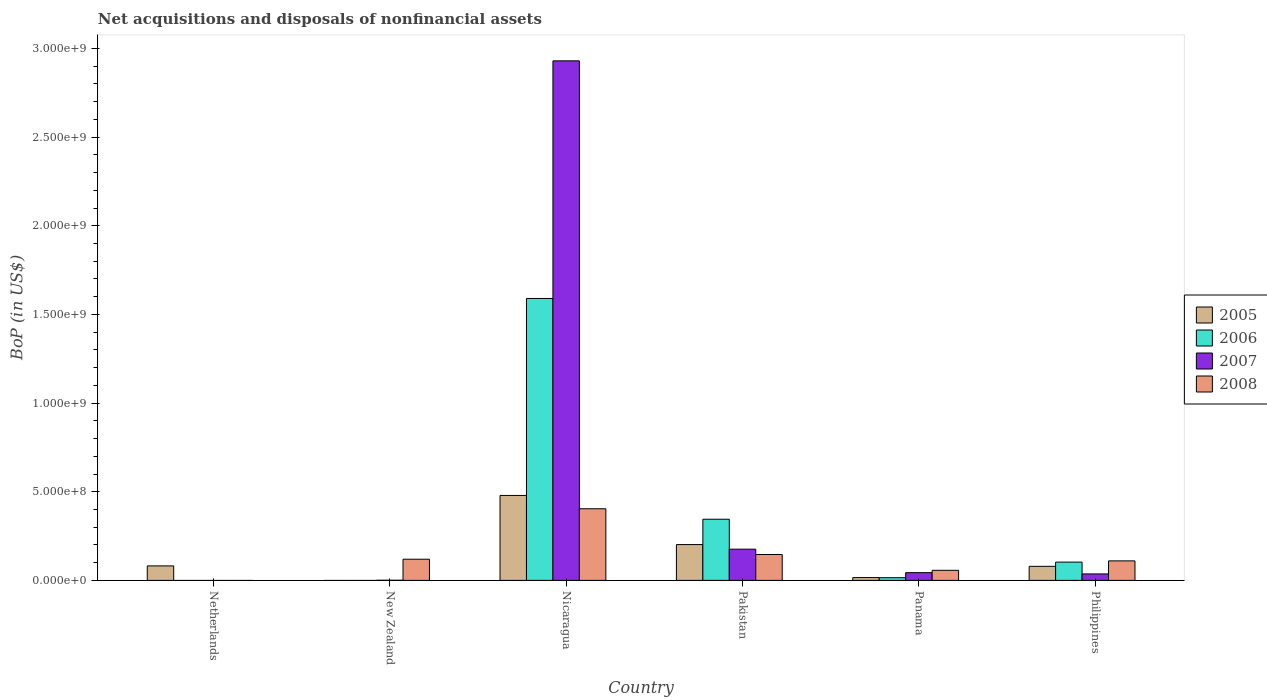Are the number of bars on each tick of the X-axis equal?
Provide a succinct answer. No. How many bars are there on the 6th tick from the left?
Provide a short and direct response. 4. How many bars are there on the 6th tick from the right?
Provide a succinct answer. 1. What is the label of the 6th group of bars from the left?
Ensure brevity in your answer.  Philippines. In how many cases, is the number of bars for a given country not equal to the number of legend labels?
Give a very brief answer. 2. What is the Balance of Payments in 2005 in Philippines?
Offer a very short reply. 7.93e+07. Across all countries, what is the maximum Balance of Payments in 2005?
Make the answer very short. 4.79e+08. Across all countries, what is the minimum Balance of Payments in 2007?
Your answer should be compact. 0. In which country was the Balance of Payments in 2005 maximum?
Offer a terse response. Nicaragua. What is the total Balance of Payments in 2006 in the graph?
Keep it short and to the point. 2.05e+09. What is the difference between the Balance of Payments in 2005 in Pakistan and that in Panama?
Offer a terse response. 1.86e+08. What is the difference between the Balance of Payments in 2007 in Pakistan and the Balance of Payments in 2008 in Nicaragua?
Offer a very short reply. -2.28e+08. What is the average Balance of Payments in 2007 per country?
Provide a short and direct response. 5.31e+08. What is the difference between the Balance of Payments of/in 2005 and Balance of Payments of/in 2008 in Panama?
Give a very brief answer. -4.11e+07. What is the ratio of the Balance of Payments in 2007 in Nicaragua to that in Philippines?
Your answer should be very brief. 80.41. Is the difference between the Balance of Payments in 2005 in Pakistan and Panama greater than the difference between the Balance of Payments in 2008 in Pakistan and Panama?
Offer a terse response. Yes. What is the difference between the highest and the second highest Balance of Payments in 2006?
Make the answer very short. 1.49e+09. What is the difference between the highest and the lowest Balance of Payments in 2008?
Provide a succinct answer. 4.04e+08. In how many countries, is the Balance of Payments in 2008 greater than the average Balance of Payments in 2008 taken over all countries?
Your response must be concise. 2. Is the sum of the Balance of Payments in 2007 in New Zealand and Philippines greater than the maximum Balance of Payments in 2005 across all countries?
Offer a terse response. No. Is it the case that in every country, the sum of the Balance of Payments in 2007 and Balance of Payments in 2008 is greater than the sum of Balance of Payments in 2005 and Balance of Payments in 2006?
Make the answer very short. No. Is it the case that in every country, the sum of the Balance of Payments in 2007 and Balance of Payments in 2006 is greater than the Balance of Payments in 2008?
Ensure brevity in your answer.  No. How many bars are there?
Make the answer very short. 19. Are all the bars in the graph horizontal?
Your answer should be very brief. No. How many countries are there in the graph?
Your answer should be compact. 6. Does the graph contain grids?
Your answer should be compact. No. Where does the legend appear in the graph?
Give a very brief answer. Center right. How many legend labels are there?
Offer a very short reply. 4. What is the title of the graph?
Give a very brief answer. Net acquisitions and disposals of nonfinancial assets. What is the label or title of the X-axis?
Your response must be concise. Country. What is the label or title of the Y-axis?
Keep it short and to the point. BoP (in US$). What is the BoP (in US$) in 2005 in Netherlands?
Offer a very short reply. 8.17e+07. What is the BoP (in US$) of 2006 in Netherlands?
Provide a short and direct response. 0. What is the BoP (in US$) in 2008 in Netherlands?
Keep it short and to the point. 0. What is the BoP (in US$) in 2006 in New Zealand?
Give a very brief answer. 0. What is the BoP (in US$) in 2007 in New Zealand?
Offer a terse response. 7.64e+05. What is the BoP (in US$) in 2008 in New Zealand?
Keep it short and to the point. 1.19e+08. What is the BoP (in US$) in 2005 in Nicaragua?
Provide a succinct answer. 4.79e+08. What is the BoP (in US$) of 2006 in Nicaragua?
Ensure brevity in your answer.  1.59e+09. What is the BoP (in US$) in 2007 in Nicaragua?
Offer a very short reply. 2.93e+09. What is the BoP (in US$) in 2008 in Nicaragua?
Your response must be concise. 4.04e+08. What is the BoP (in US$) of 2005 in Pakistan?
Provide a succinct answer. 2.02e+08. What is the BoP (in US$) in 2006 in Pakistan?
Your answer should be very brief. 3.45e+08. What is the BoP (in US$) of 2007 in Pakistan?
Give a very brief answer. 1.76e+08. What is the BoP (in US$) of 2008 in Pakistan?
Provide a succinct answer. 1.46e+08. What is the BoP (in US$) of 2005 in Panama?
Your answer should be compact. 1.58e+07. What is the BoP (in US$) in 2006 in Panama?
Your answer should be compact. 1.52e+07. What is the BoP (in US$) in 2007 in Panama?
Your answer should be compact. 4.37e+07. What is the BoP (in US$) of 2008 in Panama?
Your answer should be compact. 5.69e+07. What is the BoP (in US$) in 2005 in Philippines?
Keep it short and to the point. 7.93e+07. What is the BoP (in US$) of 2006 in Philippines?
Offer a terse response. 1.03e+08. What is the BoP (in US$) in 2007 in Philippines?
Keep it short and to the point. 3.64e+07. What is the BoP (in US$) of 2008 in Philippines?
Provide a short and direct response. 1.10e+08. Across all countries, what is the maximum BoP (in US$) of 2005?
Your answer should be compact. 4.79e+08. Across all countries, what is the maximum BoP (in US$) of 2006?
Keep it short and to the point. 1.59e+09. Across all countries, what is the maximum BoP (in US$) of 2007?
Your response must be concise. 2.93e+09. Across all countries, what is the maximum BoP (in US$) of 2008?
Your answer should be very brief. 4.04e+08. Across all countries, what is the minimum BoP (in US$) of 2005?
Give a very brief answer. 0. Across all countries, what is the minimum BoP (in US$) of 2008?
Offer a very short reply. 0. What is the total BoP (in US$) of 2005 in the graph?
Give a very brief answer. 8.58e+08. What is the total BoP (in US$) of 2006 in the graph?
Make the answer very short. 2.05e+09. What is the total BoP (in US$) in 2007 in the graph?
Your answer should be very brief. 3.19e+09. What is the total BoP (in US$) of 2008 in the graph?
Provide a short and direct response. 8.36e+08. What is the difference between the BoP (in US$) of 2005 in Netherlands and that in Nicaragua?
Offer a very short reply. -3.97e+08. What is the difference between the BoP (in US$) in 2005 in Netherlands and that in Pakistan?
Ensure brevity in your answer.  -1.20e+08. What is the difference between the BoP (in US$) of 2005 in Netherlands and that in Panama?
Provide a succinct answer. 6.59e+07. What is the difference between the BoP (in US$) of 2005 in Netherlands and that in Philippines?
Your answer should be very brief. 2.45e+06. What is the difference between the BoP (in US$) of 2007 in New Zealand and that in Nicaragua?
Your response must be concise. -2.93e+09. What is the difference between the BoP (in US$) in 2008 in New Zealand and that in Nicaragua?
Offer a terse response. -2.85e+08. What is the difference between the BoP (in US$) in 2007 in New Zealand and that in Pakistan?
Offer a terse response. -1.75e+08. What is the difference between the BoP (in US$) of 2008 in New Zealand and that in Pakistan?
Your answer should be compact. -2.66e+07. What is the difference between the BoP (in US$) in 2007 in New Zealand and that in Panama?
Your response must be concise. -4.29e+07. What is the difference between the BoP (in US$) in 2008 in New Zealand and that in Panama?
Give a very brief answer. 6.25e+07. What is the difference between the BoP (in US$) of 2007 in New Zealand and that in Philippines?
Provide a short and direct response. -3.57e+07. What is the difference between the BoP (in US$) of 2008 in New Zealand and that in Philippines?
Provide a short and direct response. 9.38e+06. What is the difference between the BoP (in US$) of 2005 in Nicaragua and that in Pakistan?
Provide a short and direct response. 2.77e+08. What is the difference between the BoP (in US$) in 2006 in Nicaragua and that in Pakistan?
Make the answer very short. 1.25e+09. What is the difference between the BoP (in US$) in 2007 in Nicaragua and that in Pakistan?
Provide a short and direct response. 2.75e+09. What is the difference between the BoP (in US$) of 2008 in Nicaragua and that in Pakistan?
Your response must be concise. 2.58e+08. What is the difference between the BoP (in US$) in 2005 in Nicaragua and that in Panama?
Offer a very short reply. 4.63e+08. What is the difference between the BoP (in US$) in 2006 in Nicaragua and that in Panama?
Your answer should be very brief. 1.58e+09. What is the difference between the BoP (in US$) in 2007 in Nicaragua and that in Panama?
Give a very brief answer. 2.89e+09. What is the difference between the BoP (in US$) in 2008 in Nicaragua and that in Panama?
Your answer should be compact. 3.47e+08. What is the difference between the BoP (in US$) of 2005 in Nicaragua and that in Philippines?
Offer a very short reply. 4.00e+08. What is the difference between the BoP (in US$) of 2006 in Nicaragua and that in Philippines?
Make the answer very short. 1.49e+09. What is the difference between the BoP (in US$) of 2007 in Nicaragua and that in Philippines?
Ensure brevity in your answer.  2.89e+09. What is the difference between the BoP (in US$) in 2008 in Nicaragua and that in Philippines?
Provide a succinct answer. 2.94e+08. What is the difference between the BoP (in US$) in 2005 in Pakistan and that in Panama?
Make the answer very short. 1.86e+08. What is the difference between the BoP (in US$) in 2006 in Pakistan and that in Panama?
Provide a short and direct response. 3.30e+08. What is the difference between the BoP (in US$) in 2007 in Pakistan and that in Panama?
Your response must be concise. 1.32e+08. What is the difference between the BoP (in US$) of 2008 in Pakistan and that in Panama?
Keep it short and to the point. 8.91e+07. What is the difference between the BoP (in US$) of 2005 in Pakistan and that in Philippines?
Ensure brevity in your answer.  1.23e+08. What is the difference between the BoP (in US$) in 2006 in Pakistan and that in Philippines?
Give a very brief answer. 2.42e+08. What is the difference between the BoP (in US$) in 2007 in Pakistan and that in Philippines?
Your answer should be compact. 1.40e+08. What is the difference between the BoP (in US$) in 2008 in Pakistan and that in Philippines?
Your response must be concise. 3.59e+07. What is the difference between the BoP (in US$) in 2005 in Panama and that in Philippines?
Offer a very short reply. -6.35e+07. What is the difference between the BoP (in US$) in 2006 in Panama and that in Philippines?
Provide a short and direct response. -8.79e+07. What is the difference between the BoP (in US$) of 2007 in Panama and that in Philippines?
Your answer should be very brief. 7.26e+06. What is the difference between the BoP (in US$) in 2008 in Panama and that in Philippines?
Make the answer very short. -5.32e+07. What is the difference between the BoP (in US$) of 2005 in Netherlands and the BoP (in US$) of 2007 in New Zealand?
Offer a very short reply. 8.10e+07. What is the difference between the BoP (in US$) in 2005 in Netherlands and the BoP (in US$) in 2008 in New Zealand?
Offer a terse response. -3.77e+07. What is the difference between the BoP (in US$) in 2005 in Netherlands and the BoP (in US$) in 2006 in Nicaragua?
Make the answer very short. -1.51e+09. What is the difference between the BoP (in US$) in 2005 in Netherlands and the BoP (in US$) in 2007 in Nicaragua?
Ensure brevity in your answer.  -2.85e+09. What is the difference between the BoP (in US$) in 2005 in Netherlands and the BoP (in US$) in 2008 in Nicaragua?
Give a very brief answer. -3.22e+08. What is the difference between the BoP (in US$) in 2005 in Netherlands and the BoP (in US$) in 2006 in Pakistan?
Ensure brevity in your answer.  -2.63e+08. What is the difference between the BoP (in US$) in 2005 in Netherlands and the BoP (in US$) in 2007 in Pakistan?
Offer a very short reply. -9.43e+07. What is the difference between the BoP (in US$) of 2005 in Netherlands and the BoP (in US$) of 2008 in Pakistan?
Your answer should be compact. -6.43e+07. What is the difference between the BoP (in US$) in 2005 in Netherlands and the BoP (in US$) in 2006 in Panama?
Provide a succinct answer. 6.65e+07. What is the difference between the BoP (in US$) in 2005 in Netherlands and the BoP (in US$) in 2007 in Panama?
Your response must be concise. 3.80e+07. What is the difference between the BoP (in US$) in 2005 in Netherlands and the BoP (in US$) in 2008 in Panama?
Keep it short and to the point. 2.48e+07. What is the difference between the BoP (in US$) of 2005 in Netherlands and the BoP (in US$) of 2006 in Philippines?
Your response must be concise. -2.14e+07. What is the difference between the BoP (in US$) of 2005 in Netherlands and the BoP (in US$) of 2007 in Philippines?
Keep it short and to the point. 4.53e+07. What is the difference between the BoP (in US$) of 2005 in Netherlands and the BoP (in US$) of 2008 in Philippines?
Offer a very short reply. -2.83e+07. What is the difference between the BoP (in US$) of 2007 in New Zealand and the BoP (in US$) of 2008 in Nicaragua?
Make the answer very short. -4.03e+08. What is the difference between the BoP (in US$) in 2007 in New Zealand and the BoP (in US$) in 2008 in Pakistan?
Your response must be concise. -1.45e+08. What is the difference between the BoP (in US$) of 2007 in New Zealand and the BoP (in US$) of 2008 in Panama?
Your answer should be very brief. -5.61e+07. What is the difference between the BoP (in US$) of 2007 in New Zealand and the BoP (in US$) of 2008 in Philippines?
Offer a very short reply. -1.09e+08. What is the difference between the BoP (in US$) in 2005 in Nicaragua and the BoP (in US$) in 2006 in Pakistan?
Offer a terse response. 1.34e+08. What is the difference between the BoP (in US$) of 2005 in Nicaragua and the BoP (in US$) of 2007 in Pakistan?
Offer a very short reply. 3.03e+08. What is the difference between the BoP (in US$) in 2005 in Nicaragua and the BoP (in US$) in 2008 in Pakistan?
Give a very brief answer. 3.33e+08. What is the difference between the BoP (in US$) in 2006 in Nicaragua and the BoP (in US$) in 2007 in Pakistan?
Provide a succinct answer. 1.41e+09. What is the difference between the BoP (in US$) of 2006 in Nicaragua and the BoP (in US$) of 2008 in Pakistan?
Your response must be concise. 1.44e+09. What is the difference between the BoP (in US$) in 2007 in Nicaragua and the BoP (in US$) in 2008 in Pakistan?
Ensure brevity in your answer.  2.78e+09. What is the difference between the BoP (in US$) in 2005 in Nicaragua and the BoP (in US$) in 2006 in Panama?
Keep it short and to the point. 4.64e+08. What is the difference between the BoP (in US$) in 2005 in Nicaragua and the BoP (in US$) in 2007 in Panama?
Give a very brief answer. 4.35e+08. What is the difference between the BoP (in US$) in 2005 in Nicaragua and the BoP (in US$) in 2008 in Panama?
Your answer should be compact. 4.22e+08. What is the difference between the BoP (in US$) in 2006 in Nicaragua and the BoP (in US$) in 2007 in Panama?
Give a very brief answer. 1.55e+09. What is the difference between the BoP (in US$) of 2006 in Nicaragua and the BoP (in US$) of 2008 in Panama?
Provide a succinct answer. 1.53e+09. What is the difference between the BoP (in US$) in 2007 in Nicaragua and the BoP (in US$) in 2008 in Panama?
Offer a very short reply. 2.87e+09. What is the difference between the BoP (in US$) of 2005 in Nicaragua and the BoP (in US$) of 2006 in Philippines?
Your answer should be compact. 3.76e+08. What is the difference between the BoP (in US$) of 2005 in Nicaragua and the BoP (in US$) of 2007 in Philippines?
Provide a short and direct response. 4.43e+08. What is the difference between the BoP (in US$) in 2005 in Nicaragua and the BoP (in US$) in 2008 in Philippines?
Ensure brevity in your answer.  3.69e+08. What is the difference between the BoP (in US$) of 2006 in Nicaragua and the BoP (in US$) of 2007 in Philippines?
Offer a terse response. 1.55e+09. What is the difference between the BoP (in US$) of 2006 in Nicaragua and the BoP (in US$) of 2008 in Philippines?
Offer a terse response. 1.48e+09. What is the difference between the BoP (in US$) in 2007 in Nicaragua and the BoP (in US$) in 2008 in Philippines?
Offer a terse response. 2.82e+09. What is the difference between the BoP (in US$) in 2005 in Pakistan and the BoP (in US$) in 2006 in Panama?
Offer a terse response. 1.87e+08. What is the difference between the BoP (in US$) of 2005 in Pakistan and the BoP (in US$) of 2007 in Panama?
Your answer should be very brief. 1.58e+08. What is the difference between the BoP (in US$) of 2005 in Pakistan and the BoP (in US$) of 2008 in Panama?
Provide a succinct answer. 1.45e+08. What is the difference between the BoP (in US$) in 2006 in Pakistan and the BoP (in US$) in 2007 in Panama?
Provide a succinct answer. 3.01e+08. What is the difference between the BoP (in US$) of 2006 in Pakistan and the BoP (in US$) of 2008 in Panama?
Offer a terse response. 2.88e+08. What is the difference between the BoP (in US$) in 2007 in Pakistan and the BoP (in US$) in 2008 in Panama?
Offer a terse response. 1.19e+08. What is the difference between the BoP (in US$) in 2005 in Pakistan and the BoP (in US$) in 2006 in Philippines?
Provide a succinct answer. 9.89e+07. What is the difference between the BoP (in US$) in 2005 in Pakistan and the BoP (in US$) in 2007 in Philippines?
Provide a succinct answer. 1.66e+08. What is the difference between the BoP (in US$) of 2005 in Pakistan and the BoP (in US$) of 2008 in Philippines?
Make the answer very short. 9.19e+07. What is the difference between the BoP (in US$) in 2006 in Pakistan and the BoP (in US$) in 2007 in Philippines?
Provide a succinct answer. 3.09e+08. What is the difference between the BoP (in US$) in 2006 in Pakistan and the BoP (in US$) in 2008 in Philippines?
Your answer should be very brief. 2.35e+08. What is the difference between the BoP (in US$) in 2007 in Pakistan and the BoP (in US$) in 2008 in Philippines?
Your answer should be very brief. 6.59e+07. What is the difference between the BoP (in US$) in 2005 in Panama and the BoP (in US$) in 2006 in Philippines?
Keep it short and to the point. -8.73e+07. What is the difference between the BoP (in US$) in 2005 in Panama and the BoP (in US$) in 2007 in Philippines?
Your answer should be very brief. -2.06e+07. What is the difference between the BoP (in US$) in 2005 in Panama and the BoP (in US$) in 2008 in Philippines?
Your response must be concise. -9.43e+07. What is the difference between the BoP (in US$) in 2006 in Panama and the BoP (in US$) in 2007 in Philippines?
Provide a succinct answer. -2.12e+07. What is the difference between the BoP (in US$) in 2006 in Panama and the BoP (in US$) in 2008 in Philippines?
Offer a terse response. -9.49e+07. What is the difference between the BoP (in US$) in 2007 in Panama and the BoP (in US$) in 2008 in Philippines?
Your answer should be very brief. -6.64e+07. What is the average BoP (in US$) in 2005 per country?
Provide a succinct answer. 1.43e+08. What is the average BoP (in US$) in 2006 per country?
Your answer should be very brief. 3.42e+08. What is the average BoP (in US$) in 2007 per country?
Your response must be concise. 5.31e+08. What is the average BoP (in US$) in 2008 per country?
Provide a short and direct response. 1.39e+08. What is the difference between the BoP (in US$) of 2007 and BoP (in US$) of 2008 in New Zealand?
Give a very brief answer. -1.19e+08. What is the difference between the BoP (in US$) in 2005 and BoP (in US$) in 2006 in Nicaragua?
Your answer should be very brief. -1.11e+09. What is the difference between the BoP (in US$) of 2005 and BoP (in US$) of 2007 in Nicaragua?
Make the answer very short. -2.45e+09. What is the difference between the BoP (in US$) in 2005 and BoP (in US$) in 2008 in Nicaragua?
Ensure brevity in your answer.  7.51e+07. What is the difference between the BoP (in US$) in 2006 and BoP (in US$) in 2007 in Nicaragua?
Keep it short and to the point. -1.34e+09. What is the difference between the BoP (in US$) of 2006 and BoP (in US$) of 2008 in Nicaragua?
Keep it short and to the point. 1.19e+09. What is the difference between the BoP (in US$) of 2007 and BoP (in US$) of 2008 in Nicaragua?
Provide a succinct answer. 2.53e+09. What is the difference between the BoP (in US$) of 2005 and BoP (in US$) of 2006 in Pakistan?
Offer a very short reply. -1.43e+08. What is the difference between the BoP (in US$) of 2005 and BoP (in US$) of 2007 in Pakistan?
Provide a succinct answer. 2.60e+07. What is the difference between the BoP (in US$) in 2005 and BoP (in US$) in 2008 in Pakistan?
Give a very brief answer. 5.60e+07. What is the difference between the BoP (in US$) in 2006 and BoP (in US$) in 2007 in Pakistan?
Your answer should be very brief. 1.69e+08. What is the difference between the BoP (in US$) in 2006 and BoP (in US$) in 2008 in Pakistan?
Your response must be concise. 1.99e+08. What is the difference between the BoP (in US$) in 2007 and BoP (in US$) in 2008 in Pakistan?
Provide a succinct answer. 3.00e+07. What is the difference between the BoP (in US$) of 2005 and BoP (in US$) of 2007 in Panama?
Provide a short and direct response. -2.79e+07. What is the difference between the BoP (in US$) of 2005 and BoP (in US$) of 2008 in Panama?
Your answer should be very brief. -4.11e+07. What is the difference between the BoP (in US$) in 2006 and BoP (in US$) in 2007 in Panama?
Keep it short and to the point. -2.85e+07. What is the difference between the BoP (in US$) in 2006 and BoP (in US$) in 2008 in Panama?
Provide a short and direct response. -4.17e+07. What is the difference between the BoP (in US$) in 2007 and BoP (in US$) in 2008 in Panama?
Offer a very short reply. -1.32e+07. What is the difference between the BoP (in US$) in 2005 and BoP (in US$) in 2006 in Philippines?
Your response must be concise. -2.38e+07. What is the difference between the BoP (in US$) in 2005 and BoP (in US$) in 2007 in Philippines?
Provide a short and direct response. 4.28e+07. What is the difference between the BoP (in US$) in 2005 and BoP (in US$) in 2008 in Philippines?
Offer a terse response. -3.08e+07. What is the difference between the BoP (in US$) of 2006 and BoP (in US$) of 2007 in Philippines?
Ensure brevity in your answer.  6.67e+07. What is the difference between the BoP (in US$) of 2006 and BoP (in US$) of 2008 in Philippines?
Offer a terse response. -6.96e+06. What is the difference between the BoP (in US$) in 2007 and BoP (in US$) in 2008 in Philippines?
Your answer should be compact. -7.36e+07. What is the ratio of the BoP (in US$) in 2005 in Netherlands to that in Nicaragua?
Your answer should be compact. 0.17. What is the ratio of the BoP (in US$) of 2005 in Netherlands to that in Pakistan?
Ensure brevity in your answer.  0.4. What is the ratio of the BoP (in US$) in 2005 in Netherlands to that in Panama?
Your answer should be compact. 5.17. What is the ratio of the BoP (in US$) in 2005 in Netherlands to that in Philippines?
Ensure brevity in your answer.  1.03. What is the ratio of the BoP (in US$) of 2008 in New Zealand to that in Nicaragua?
Provide a succinct answer. 0.3. What is the ratio of the BoP (in US$) in 2007 in New Zealand to that in Pakistan?
Your answer should be very brief. 0. What is the ratio of the BoP (in US$) in 2008 in New Zealand to that in Pakistan?
Keep it short and to the point. 0.82. What is the ratio of the BoP (in US$) of 2007 in New Zealand to that in Panama?
Offer a very short reply. 0.02. What is the ratio of the BoP (in US$) in 2008 in New Zealand to that in Panama?
Ensure brevity in your answer.  2.1. What is the ratio of the BoP (in US$) of 2007 in New Zealand to that in Philippines?
Offer a terse response. 0.02. What is the ratio of the BoP (in US$) in 2008 in New Zealand to that in Philippines?
Ensure brevity in your answer.  1.09. What is the ratio of the BoP (in US$) of 2005 in Nicaragua to that in Pakistan?
Give a very brief answer. 2.37. What is the ratio of the BoP (in US$) of 2006 in Nicaragua to that in Pakistan?
Your response must be concise. 4.61. What is the ratio of the BoP (in US$) of 2007 in Nicaragua to that in Pakistan?
Provide a succinct answer. 16.65. What is the ratio of the BoP (in US$) of 2008 in Nicaragua to that in Pakistan?
Keep it short and to the point. 2.77. What is the ratio of the BoP (in US$) in 2005 in Nicaragua to that in Panama?
Ensure brevity in your answer.  30.32. What is the ratio of the BoP (in US$) in 2006 in Nicaragua to that in Panama?
Your answer should be very brief. 104.62. What is the ratio of the BoP (in US$) of 2007 in Nicaragua to that in Panama?
Provide a short and direct response. 67.06. What is the ratio of the BoP (in US$) of 2008 in Nicaragua to that in Panama?
Provide a short and direct response. 7.1. What is the ratio of the BoP (in US$) in 2005 in Nicaragua to that in Philippines?
Offer a terse response. 6.04. What is the ratio of the BoP (in US$) of 2006 in Nicaragua to that in Philippines?
Provide a short and direct response. 15.42. What is the ratio of the BoP (in US$) in 2007 in Nicaragua to that in Philippines?
Keep it short and to the point. 80.41. What is the ratio of the BoP (in US$) of 2008 in Nicaragua to that in Philippines?
Offer a terse response. 3.67. What is the ratio of the BoP (in US$) of 2005 in Pakistan to that in Panama?
Ensure brevity in your answer.  12.78. What is the ratio of the BoP (in US$) in 2006 in Pakistan to that in Panama?
Provide a short and direct response. 22.7. What is the ratio of the BoP (in US$) of 2007 in Pakistan to that in Panama?
Give a very brief answer. 4.03. What is the ratio of the BoP (in US$) in 2008 in Pakistan to that in Panama?
Make the answer very short. 2.57. What is the ratio of the BoP (in US$) of 2005 in Pakistan to that in Philippines?
Ensure brevity in your answer.  2.55. What is the ratio of the BoP (in US$) of 2006 in Pakistan to that in Philippines?
Your answer should be compact. 3.35. What is the ratio of the BoP (in US$) in 2007 in Pakistan to that in Philippines?
Provide a succinct answer. 4.83. What is the ratio of the BoP (in US$) of 2008 in Pakistan to that in Philippines?
Offer a very short reply. 1.33. What is the ratio of the BoP (in US$) of 2005 in Panama to that in Philippines?
Give a very brief answer. 0.2. What is the ratio of the BoP (in US$) of 2006 in Panama to that in Philippines?
Provide a succinct answer. 0.15. What is the ratio of the BoP (in US$) of 2007 in Panama to that in Philippines?
Give a very brief answer. 1.2. What is the ratio of the BoP (in US$) of 2008 in Panama to that in Philippines?
Provide a short and direct response. 0.52. What is the difference between the highest and the second highest BoP (in US$) of 2005?
Your answer should be compact. 2.77e+08. What is the difference between the highest and the second highest BoP (in US$) in 2006?
Provide a succinct answer. 1.25e+09. What is the difference between the highest and the second highest BoP (in US$) of 2007?
Your answer should be very brief. 2.75e+09. What is the difference between the highest and the second highest BoP (in US$) in 2008?
Your response must be concise. 2.58e+08. What is the difference between the highest and the lowest BoP (in US$) of 2005?
Give a very brief answer. 4.79e+08. What is the difference between the highest and the lowest BoP (in US$) in 2006?
Your answer should be very brief. 1.59e+09. What is the difference between the highest and the lowest BoP (in US$) of 2007?
Ensure brevity in your answer.  2.93e+09. What is the difference between the highest and the lowest BoP (in US$) in 2008?
Your answer should be very brief. 4.04e+08. 